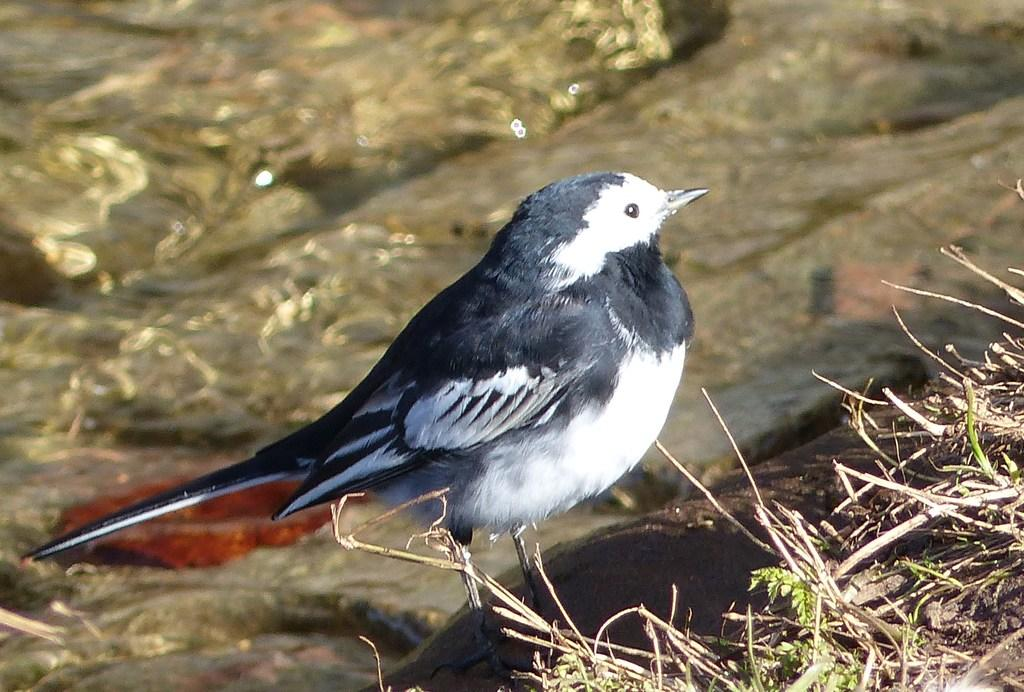What type of animal is in the image? There is a bird in the image. What type of vegetation is present in the image? There is grass in the image. What geological feature can be seen in the background of the image? There is a rock in the background of the image. What type of scarf is the bird wearing in the image? There is no scarf present in the image; the bird is not wearing any clothing. 